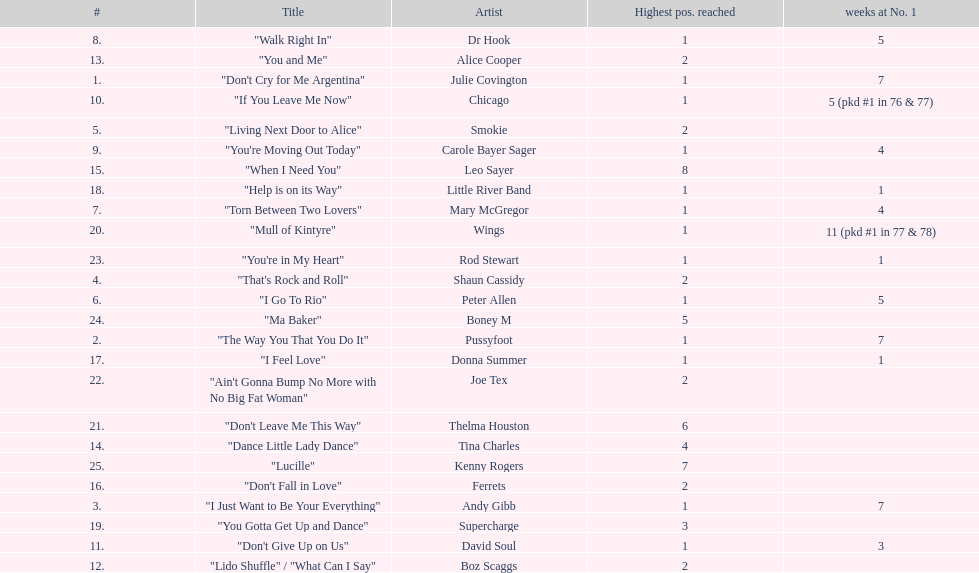Which three artists had a single at number 1 for at least 7 weeks on the australian singles charts in 1977? Julie Covington, Pussyfoot, Andy Gibb. 